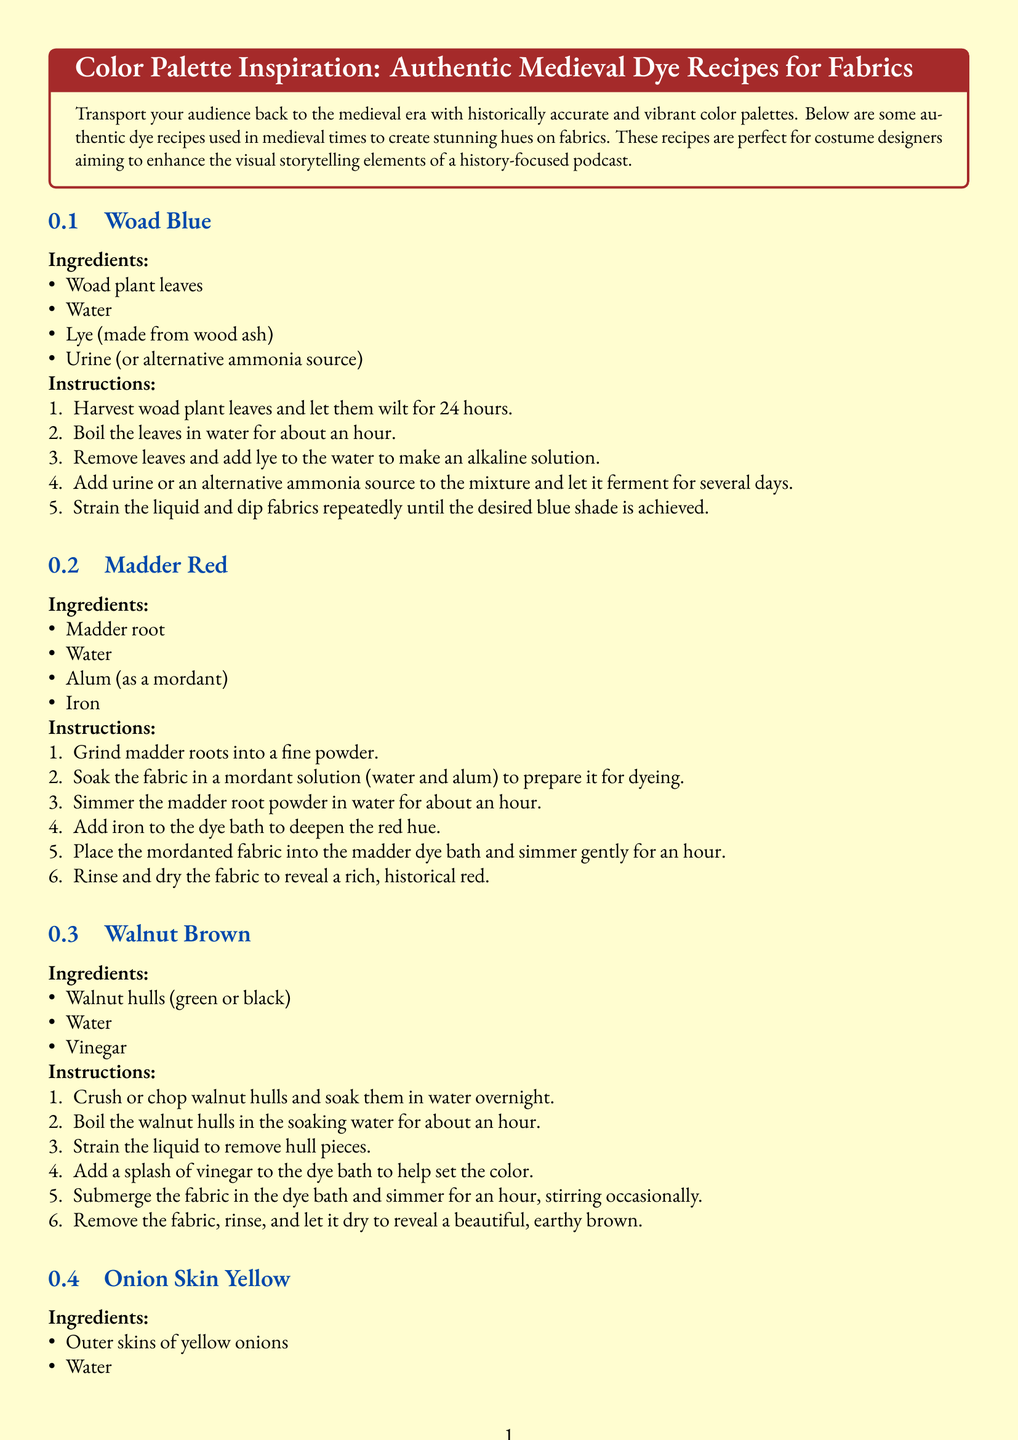What is the color achieved by the woad dye? The document describes the use of woad to create a blue color for fabrics.
Answer: Blue What is used as a mordant in the madder red recipe? The document states that alum is used as a mordant in the madder red recipe to prepare the fabric for dyeing.
Answer: Alum How long should the onion skins be boiled in water? The recipe for onion skin yellow indicates a boiling duration of 30-45 minutes.
Answer: 30-45 minutes What is added to the walnut dye bath to help set the color? The walnut brown dye recipe specifies adding a splash of vinegar to the dye bath to help set the color.
Answer: Vinegar Which plant is used to produce madder red? The document notes that madder root is used to create the madder red dye.
Answer: Madder root What temperature is needed to simmer the madder root powder? The instructions for madder red indicate that the mixture should be simmered gently for an hour, which implies a low to moderate heat.
Answer: Simmer gently What color does the onion skin dye create? The document describes the resulting color from the onion skin dye as a warm, golden yellow.
Answer: Golden yellow What is the purpose of using mordants in fabric dyeing? The note at the end of the document suggests that mordants like alum fix the dye to the fabric and enhance color durability.
Answer: Fix dye What feature distinguishes the document type? This document presents recipes specifically intended for dyeing fabrics, detailing ingredients and instructions which is typical for a recipe card.
Answer: Recipes for dyeing fabrics 